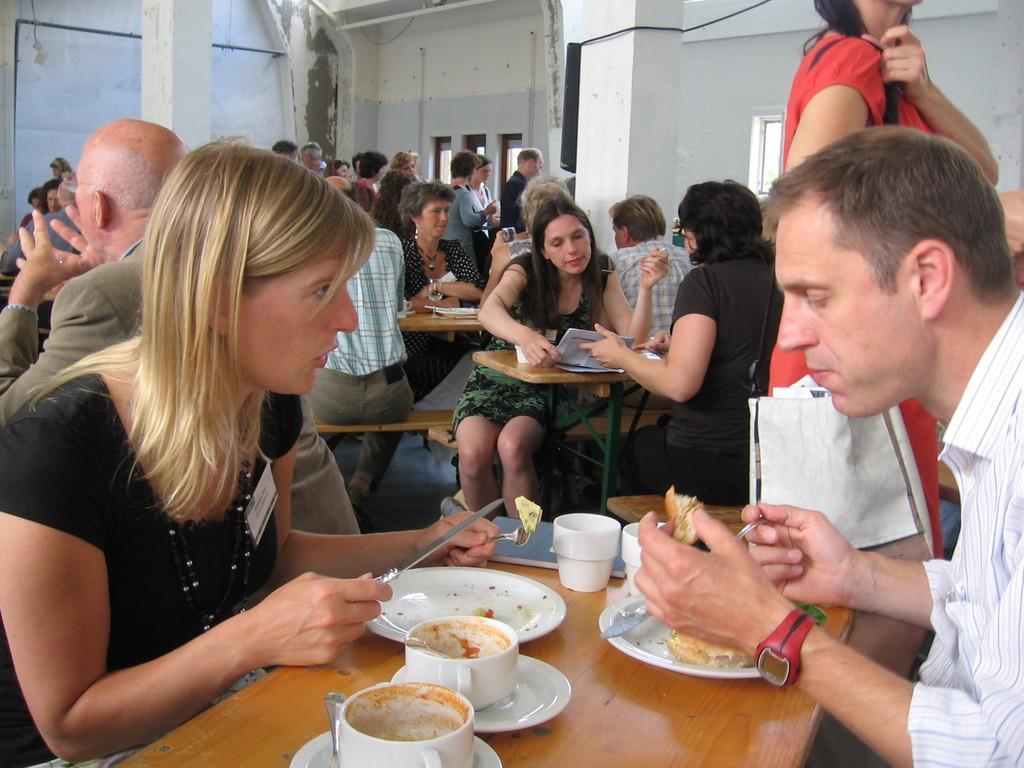Can you describe this image briefly? In this picture I can observe some people sitting on the benches in front of their respective tables. There are men and women in this picture. I can observe cups, plates and knives on the table. On the right side there is a woman walking on the floor. In the background there is a wall. 